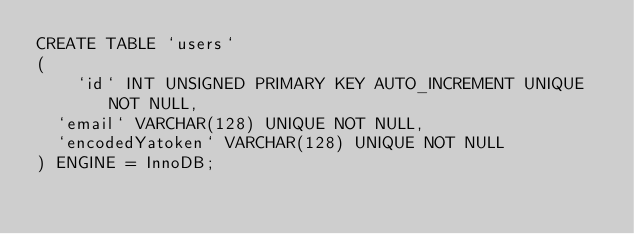<code> <loc_0><loc_0><loc_500><loc_500><_SQL_>CREATE TABLE `users`
(
    `id` INT UNSIGNED PRIMARY KEY AUTO_INCREMENT UNIQUE NOT NULL,
	`email` VARCHAR(128) UNIQUE NOT NULL,
	`encodedYatoken` VARCHAR(128) UNIQUE NOT NULL
) ENGINE = InnoDB;
</code> 